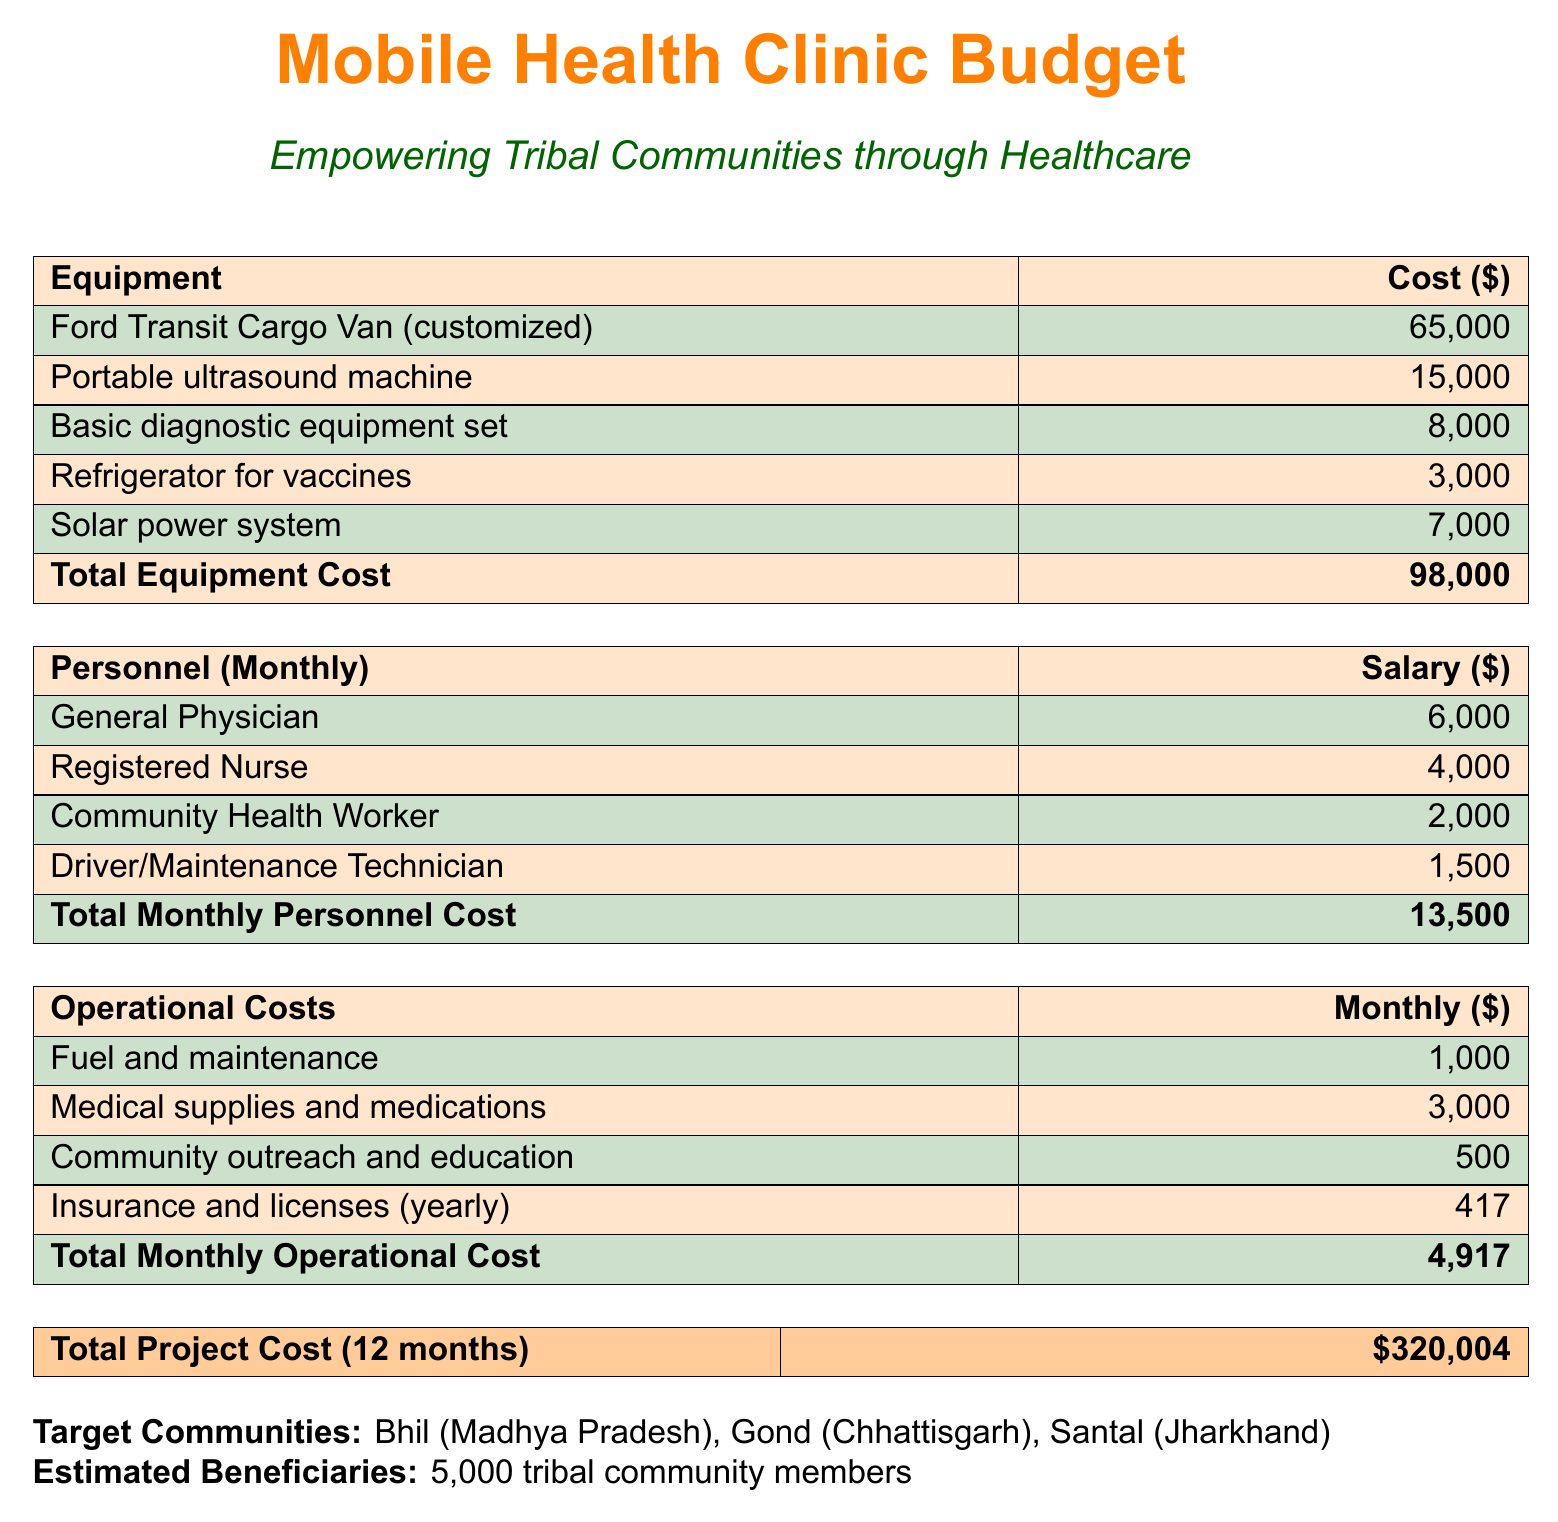What is the total equipment cost? The total equipment cost is provided as the sum of all equipment costs listed in the budget.
Answer: 98,000 What is the monthly salary of a General Physician? The monthly salary for a General Physician is specified in the personnel section of the budget.
Answer: 6,000 How many tribal community members are estimated to benefit? The document states the estimated number of beneficiaries from the mobile health clinic service.
Answer: 5,000 What is the cost of the portable ultrasound machine? The cost for the portable ultrasound machine is listed under the equipment section.
Answer: 15,000 What is the total monthly personnel cost? The total monthly personnel cost is the sum of all individual salaries listed for personnel.
Answer: 13,500 What are the target communities? The document lists the target communities that the mobile health clinic service aims to serve.
Answer: Bhil, Gond, Santal What are the operational costs for fuel and maintenance? The monthly operational costs for fuel and maintenance are provided in the operational costs section.
Answer: 1,000 What is the total project cost for 12 months? The total project cost is calculated as the cumulative sum of all monthly costs over a year, as shown in the document.
Answer: 320,004 What is the cost of the solar power system? The specific cost of the solar power system is noted in the equipment table.
Answer: 7,000 What is included in the community outreach and education cost? The cost allocated for community outreach and education is itemized in the operational costs section.
Answer: 500 